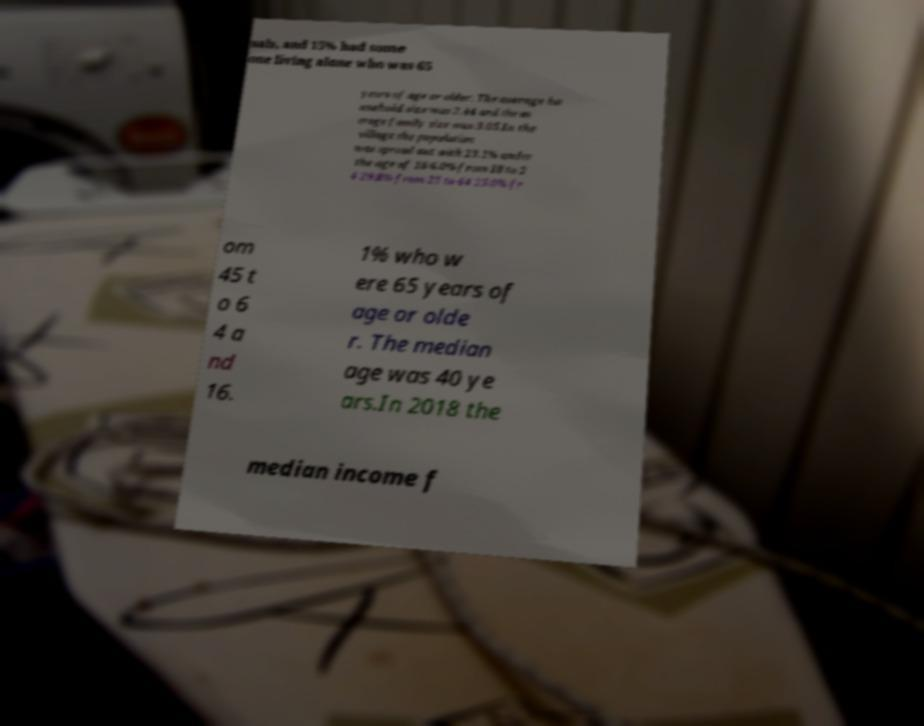Please identify and transcribe the text found in this image. uals, and 15% had some one living alone who was 65 years of age or older. The average ho usehold size was 2.44 and the av erage family size was 3.05.In the village the population was spread out with 23.1% under the age of 18 6.0% from 18 to 2 4 29.8% from 25 to 44 25.0% fr om 45 t o 6 4 a nd 16. 1% who w ere 65 years of age or olde r. The median age was 40 ye ars.In 2018 the median income f 